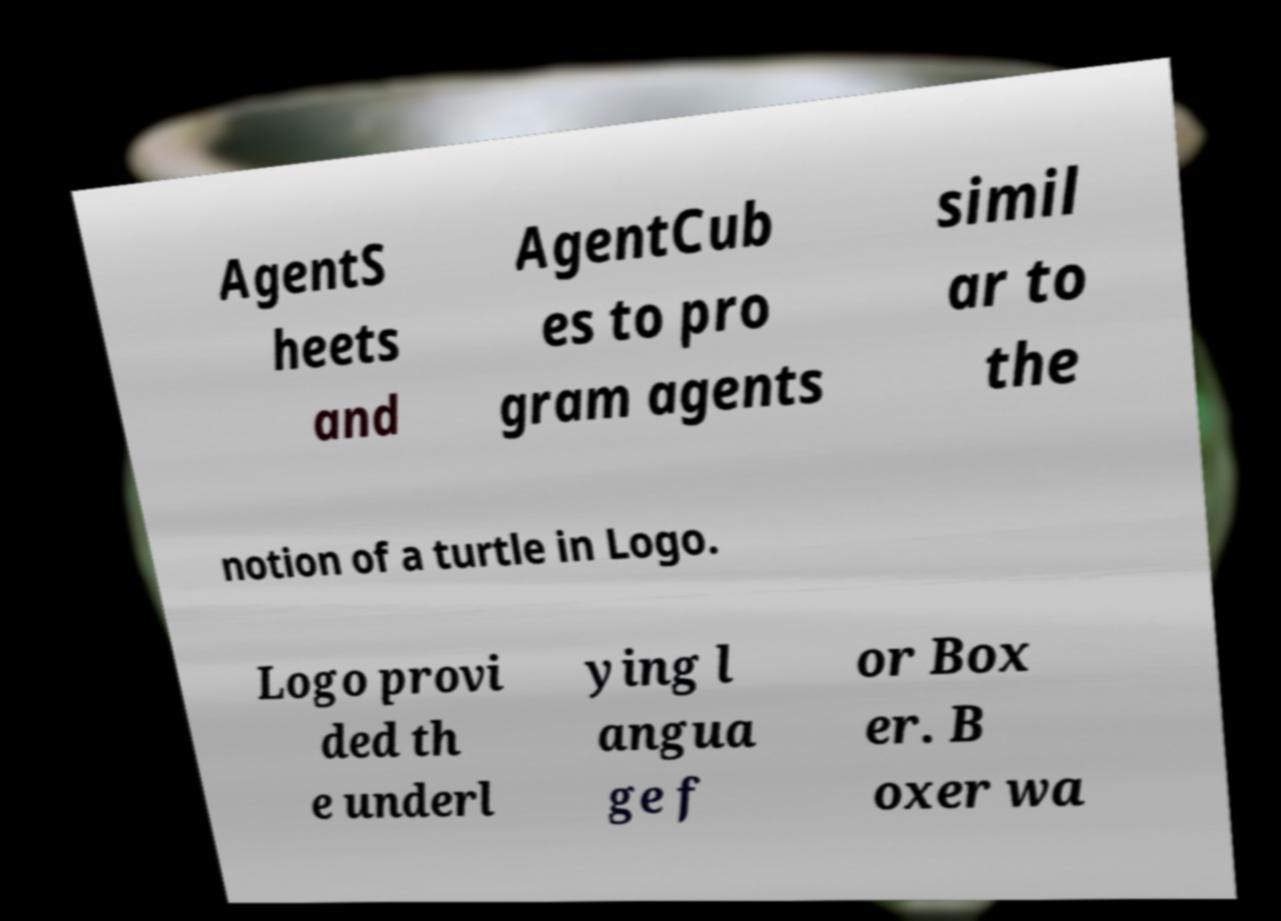Can you read and provide the text displayed in the image?This photo seems to have some interesting text. Can you extract and type it out for me? AgentS heets and AgentCub es to pro gram agents simil ar to the notion of a turtle in Logo. Logo provi ded th e underl ying l angua ge f or Box er. B oxer wa 